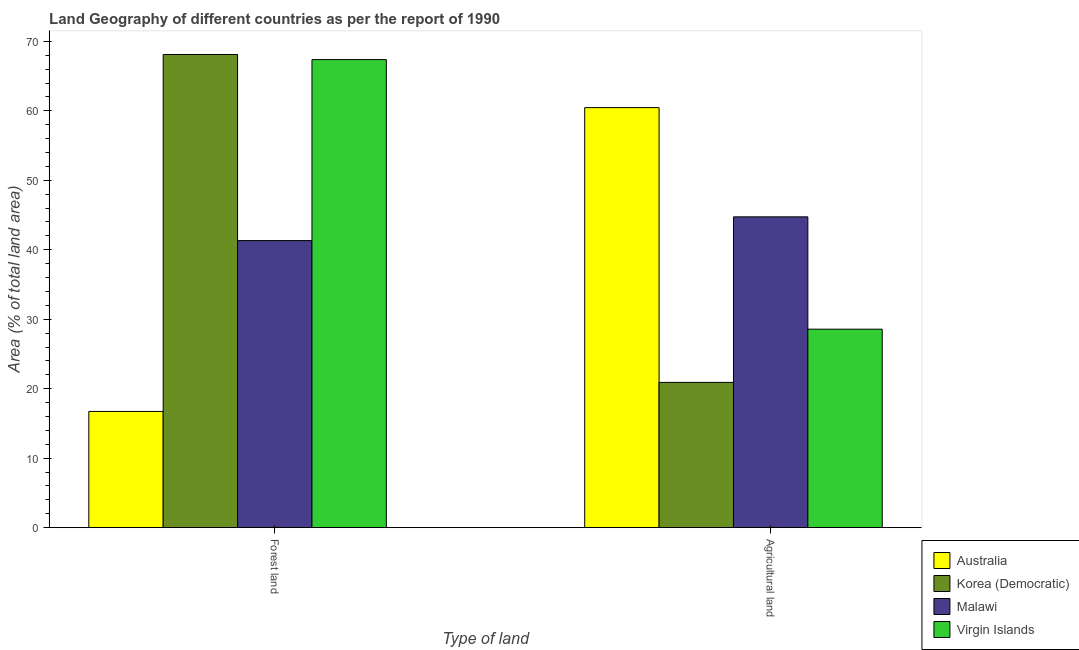Are the number of bars per tick equal to the number of legend labels?
Offer a very short reply. Yes. Are the number of bars on each tick of the X-axis equal?
Offer a very short reply. Yes. How many bars are there on the 2nd tick from the right?
Keep it short and to the point. 4. What is the label of the 1st group of bars from the left?
Offer a terse response. Forest land. What is the percentage of land area under forests in Virgin Islands?
Make the answer very short. 67.37. Across all countries, what is the maximum percentage of land area under agriculture?
Keep it short and to the point. 60.46. Across all countries, what is the minimum percentage of land area under agriculture?
Your answer should be compact. 20.91. In which country was the percentage of land area under forests maximum?
Give a very brief answer. Korea (Democratic). What is the total percentage of land area under agriculture in the graph?
Offer a terse response. 154.68. What is the difference between the percentage of land area under forests in Korea (Democratic) and that in Malawi?
Keep it short and to the point. 26.79. What is the difference between the percentage of land area under forests in Malawi and the percentage of land area under agriculture in Virgin Islands?
Your response must be concise. 12.75. What is the average percentage of land area under forests per country?
Provide a succinct answer. 48.38. What is the difference between the percentage of land area under forests and percentage of land area under agriculture in Korea (Democratic)?
Provide a succinct answer. 47.2. In how many countries, is the percentage of land area under forests greater than 10 %?
Make the answer very short. 4. What is the ratio of the percentage of land area under forests in Malawi to that in Australia?
Offer a terse response. 2.47. Is the percentage of land area under forests in Australia less than that in Korea (Democratic)?
Your answer should be compact. Yes. What does the 2nd bar from the left in Forest land represents?
Offer a very short reply. Korea (Democratic). What does the 2nd bar from the right in Agricultural land represents?
Your answer should be compact. Malawi. What is the difference between two consecutive major ticks on the Y-axis?
Offer a terse response. 10. Are the values on the major ticks of Y-axis written in scientific E-notation?
Keep it short and to the point. No. Where does the legend appear in the graph?
Your answer should be compact. Bottom right. How many legend labels are there?
Ensure brevity in your answer.  4. How are the legend labels stacked?
Give a very brief answer. Vertical. What is the title of the graph?
Offer a terse response. Land Geography of different countries as per the report of 1990. What is the label or title of the X-axis?
Your answer should be compact. Type of land. What is the label or title of the Y-axis?
Keep it short and to the point. Area (% of total land area). What is the Area (% of total land area) in Australia in Forest land?
Give a very brief answer. 16.73. What is the Area (% of total land area) in Korea (Democratic) in Forest land?
Ensure brevity in your answer.  68.11. What is the Area (% of total land area) in Malawi in Forest land?
Provide a short and direct response. 41.32. What is the Area (% of total land area) in Virgin Islands in Forest land?
Provide a short and direct response. 67.37. What is the Area (% of total land area) in Australia in Agricultural land?
Offer a very short reply. 60.46. What is the Area (% of total land area) of Korea (Democratic) in Agricultural land?
Your answer should be compact. 20.91. What is the Area (% of total land area) in Malawi in Agricultural land?
Your answer should be very brief. 44.74. What is the Area (% of total land area) in Virgin Islands in Agricultural land?
Ensure brevity in your answer.  28.57. Across all Type of land, what is the maximum Area (% of total land area) of Australia?
Give a very brief answer. 60.46. Across all Type of land, what is the maximum Area (% of total land area) of Korea (Democratic)?
Provide a short and direct response. 68.11. Across all Type of land, what is the maximum Area (% of total land area) in Malawi?
Provide a succinct answer. 44.74. Across all Type of land, what is the maximum Area (% of total land area) of Virgin Islands?
Keep it short and to the point. 67.37. Across all Type of land, what is the minimum Area (% of total land area) in Australia?
Your answer should be compact. 16.73. Across all Type of land, what is the minimum Area (% of total land area) in Korea (Democratic)?
Offer a very short reply. 20.91. Across all Type of land, what is the minimum Area (% of total land area) in Malawi?
Keep it short and to the point. 41.32. Across all Type of land, what is the minimum Area (% of total land area) of Virgin Islands?
Ensure brevity in your answer.  28.57. What is the total Area (% of total land area) of Australia in the graph?
Keep it short and to the point. 77.19. What is the total Area (% of total land area) of Korea (Democratic) in the graph?
Make the answer very short. 89.02. What is the total Area (% of total land area) in Malawi in the graph?
Your answer should be very brief. 86.06. What is the total Area (% of total land area) of Virgin Islands in the graph?
Your answer should be compact. 95.94. What is the difference between the Area (% of total land area) of Australia in Forest land and that in Agricultural land?
Ensure brevity in your answer.  -43.73. What is the difference between the Area (% of total land area) in Korea (Democratic) in Forest land and that in Agricultural land?
Your response must be concise. 47.2. What is the difference between the Area (% of total land area) of Malawi in Forest land and that in Agricultural land?
Your answer should be compact. -3.42. What is the difference between the Area (% of total land area) in Virgin Islands in Forest land and that in Agricultural land?
Provide a succinct answer. 38.8. What is the difference between the Area (% of total land area) of Australia in Forest land and the Area (% of total land area) of Korea (Democratic) in Agricultural land?
Ensure brevity in your answer.  -4.18. What is the difference between the Area (% of total land area) in Australia in Forest land and the Area (% of total land area) in Malawi in Agricultural land?
Keep it short and to the point. -28.01. What is the difference between the Area (% of total land area) of Australia in Forest land and the Area (% of total land area) of Virgin Islands in Agricultural land?
Offer a terse response. -11.84. What is the difference between the Area (% of total land area) of Korea (Democratic) in Forest land and the Area (% of total land area) of Malawi in Agricultural land?
Your answer should be compact. 23.37. What is the difference between the Area (% of total land area) in Korea (Democratic) in Forest land and the Area (% of total land area) in Virgin Islands in Agricultural land?
Your response must be concise. 39.54. What is the difference between the Area (% of total land area) in Malawi in Forest land and the Area (% of total land area) in Virgin Islands in Agricultural land?
Provide a short and direct response. 12.75. What is the average Area (% of total land area) in Australia per Type of land?
Make the answer very short. 38.6. What is the average Area (% of total land area) of Korea (Democratic) per Type of land?
Ensure brevity in your answer.  44.51. What is the average Area (% of total land area) of Malawi per Type of land?
Make the answer very short. 43.03. What is the average Area (% of total land area) of Virgin Islands per Type of land?
Offer a terse response. 47.97. What is the difference between the Area (% of total land area) in Australia and Area (% of total land area) in Korea (Democratic) in Forest land?
Ensure brevity in your answer.  -51.38. What is the difference between the Area (% of total land area) in Australia and Area (% of total land area) in Malawi in Forest land?
Provide a short and direct response. -24.59. What is the difference between the Area (% of total land area) in Australia and Area (% of total land area) in Virgin Islands in Forest land?
Provide a short and direct response. -50.64. What is the difference between the Area (% of total land area) of Korea (Democratic) and Area (% of total land area) of Malawi in Forest land?
Give a very brief answer. 26.79. What is the difference between the Area (% of total land area) in Korea (Democratic) and Area (% of total land area) in Virgin Islands in Forest land?
Your response must be concise. 0.74. What is the difference between the Area (% of total land area) in Malawi and Area (% of total land area) in Virgin Islands in Forest land?
Offer a terse response. -26.05. What is the difference between the Area (% of total land area) of Australia and Area (% of total land area) of Korea (Democratic) in Agricultural land?
Provide a short and direct response. 39.55. What is the difference between the Area (% of total land area) of Australia and Area (% of total land area) of Malawi in Agricultural land?
Your answer should be compact. 15.72. What is the difference between the Area (% of total land area) of Australia and Area (% of total land area) of Virgin Islands in Agricultural land?
Your response must be concise. 31.89. What is the difference between the Area (% of total land area) in Korea (Democratic) and Area (% of total land area) in Malawi in Agricultural land?
Ensure brevity in your answer.  -23.83. What is the difference between the Area (% of total land area) of Korea (Democratic) and Area (% of total land area) of Virgin Islands in Agricultural land?
Make the answer very short. -7.66. What is the difference between the Area (% of total land area) of Malawi and Area (% of total land area) of Virgin Islands in Agricultural land?
Make the answer very short. 16.17. What is the ratio of the Area (% of total land area) of Australia in Forest land to that in Agricultural land?
Make the answer very short. 0.28. What is the ratio of the Area (% of total land area) of Korea (Democratic) in Forest land to that in Agricultural land?
Offer a very short reply. 3.26. What is the ratio of the Area (% of total land area) of Malawi in Forest land to that in Agricultural land?
Offer a very short reply. 0.92. What is the ratio of the Area (% of total land area) in Virgin Islands in Forest land to that in Agricultural land?
Give a very brief answer. 2.36. What is the difference between the highest and the second highest Area (% of total land area) of Australia?
Keep it short and to the point. 43.73. What is the difference between the highest and the second highest Area (% of total land area) in Korea (Democratic)?
Make the answer very short. 47.2. What is the difference between the highest and the second highest Area (% of total land area) in Malawi?
Make the answer very short. 3.42. What is the difference between the highest and the second highest Area (% of total land area) of Virgin Islands?
Provide a succinct answer. 38.8. What is the difference between the highest and the lowest Area (% of total land area) in Australia?
Offer a very short reply. 43.73. What is the difference between the highest and the lowest Area (% of total land area) of Korea (Democratic)?
Offer a terse response. 47.2. What is the difference between the highest and the lowest Area (% of total land area) of Malawi?
Make the answer very short. 3.42. What is the difference between the highest and the lowest Area (% of total land area) of Virgin Islands?
Offer a terse response. 38.8. 